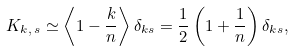<formula> <loc_0><loc_0><loc_500><loc_500>K _ { k , \, s } \simeq \left \langle 1 - \frac { k } { n } \right \rangle \delta _ { k s } = \frac { 1 } { 2 } \left ( 1 + \frac { 1 } { n } \right ) \delta _ { k s } ,</formula> 